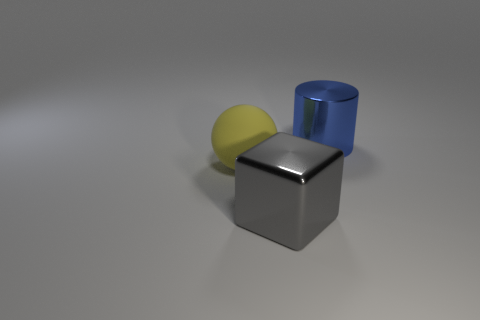How big is the metal object that is in front of the metallic cylinder on the right side of the object that is left of the block?
Offer a terse response. Large. What is the color of the thing that is to the right of the big metal object that is in front of the cylinder?
Your response must be concise. Blue. Is there any other thing that has the same material as the large gray block?
Offer a terse response. Yes. Are there any things left of the blue shiny cylinder?
Give a very brief answer. Yes. How many small yellow metal cubes are there?
Provide a succinct answer. 0. How many big rubber things are on the right side of the metallic thing that is in front of the big blue metallic object?
Your answer should be compact. 0. Is the color of the large matte ball the same as the large metal thing that is on the left side of the cylinder?
Your response must be concise. No. What is the material of the big thing that is right of the shiny block?
Ensure brevity in your answer.  Metal. Do the large thing behind the large ball and the gray metal object have the same shape?
Give a very brief answer. No. Is there a yellow matte sphere of the same size as the gray thing?
Provide a short and direct response. Yes. 